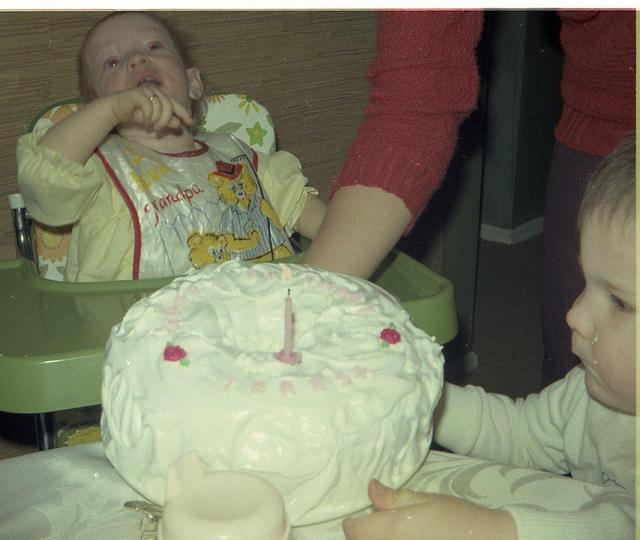Why is there a candle in the cake?

Choices:
A) to celebrate
B) for light
C) to eat
D) to cook to celebrate 